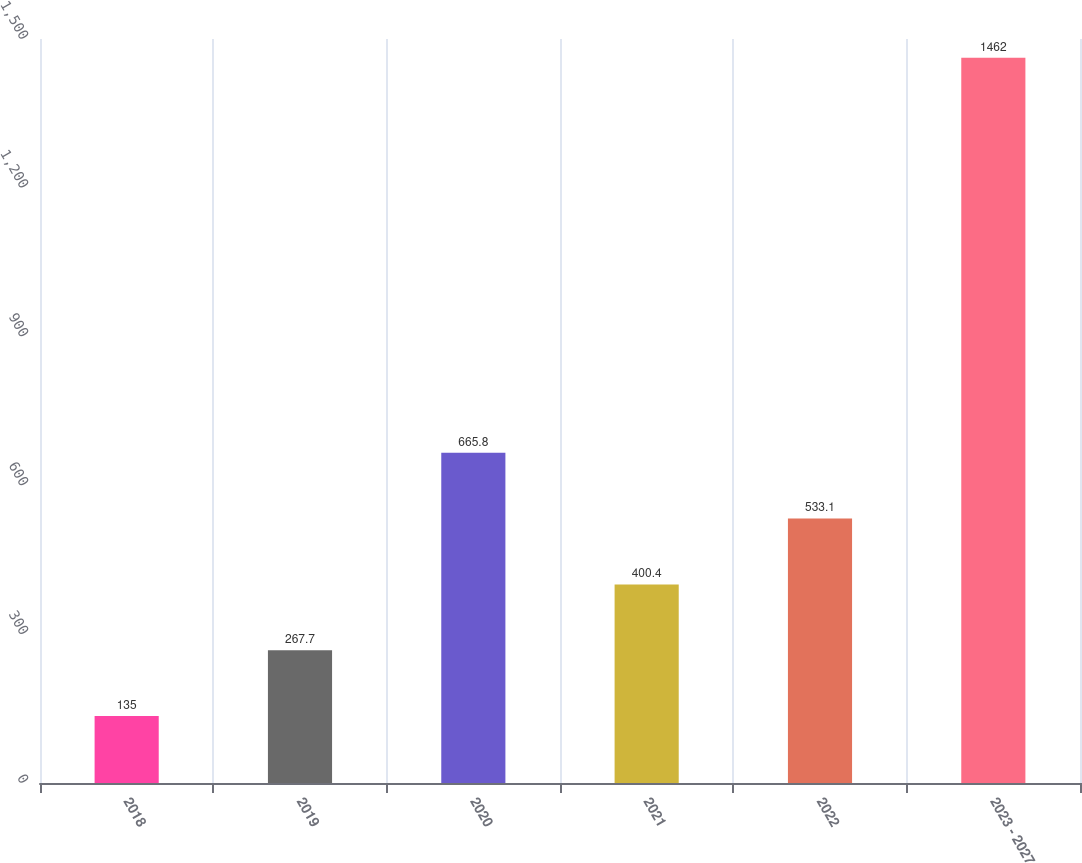Convert chart. <chart><loc_0><loc_0><loc_500><loc_500><bar_chart><fcel>2018<fcel>2019<fcel>2020<fcel>2021<fcel>2022<fcel>2023 - 2027<nl><fcel>135<fcel>267.7<fcel>665.8<fcel>400.4<fcel>533.1<fcel>1462<nl></chart> 